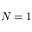Convert formula to latex. <formula><loc_0><loc_0><loc_500><loc_500>N = 1</formula> 